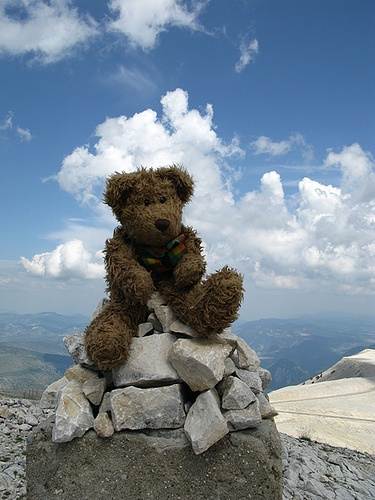Describe the objects in this image and their specific colors. I can see a teddy bear in darkgray, black, and gray tones in this image. 